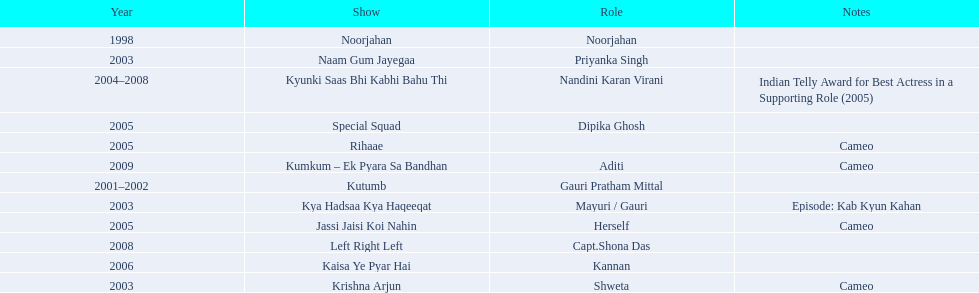On what shows did gauri pradhan tejwani appear after 2000? Kutumb, Krishna Arjun, Naam Gum Jayegaa, Kya Hadsaa Kya Haqeeqat, Kyunki Saas Bhi Kabhi Bahu Thi, Rihaae, Jassi Jaisi Koi Nahin, Special Squad, Kaisa Ye Pyar Hai, Left Right Left, Kumkum – Ek Pyara Sa Bandhan. In which of them was is a cameo appearance? Krishna Arjun, Rihaae, Jassi Jaisi Koi Nahin, Kumkum – Ek Pyara Sa Bandhan. Of these which one did she play the role of herself? Jassi Jaisi Koi Nahin. 